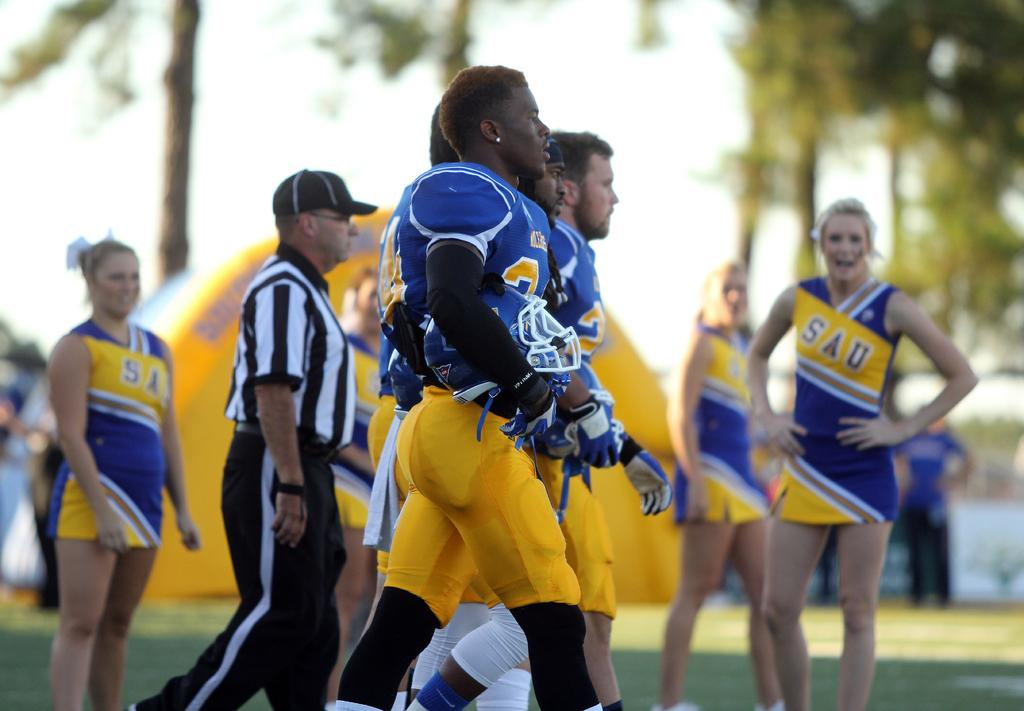<image>
Describe the image concisely. SAU's football team walks towards the field as their cheerleaders watch on. 